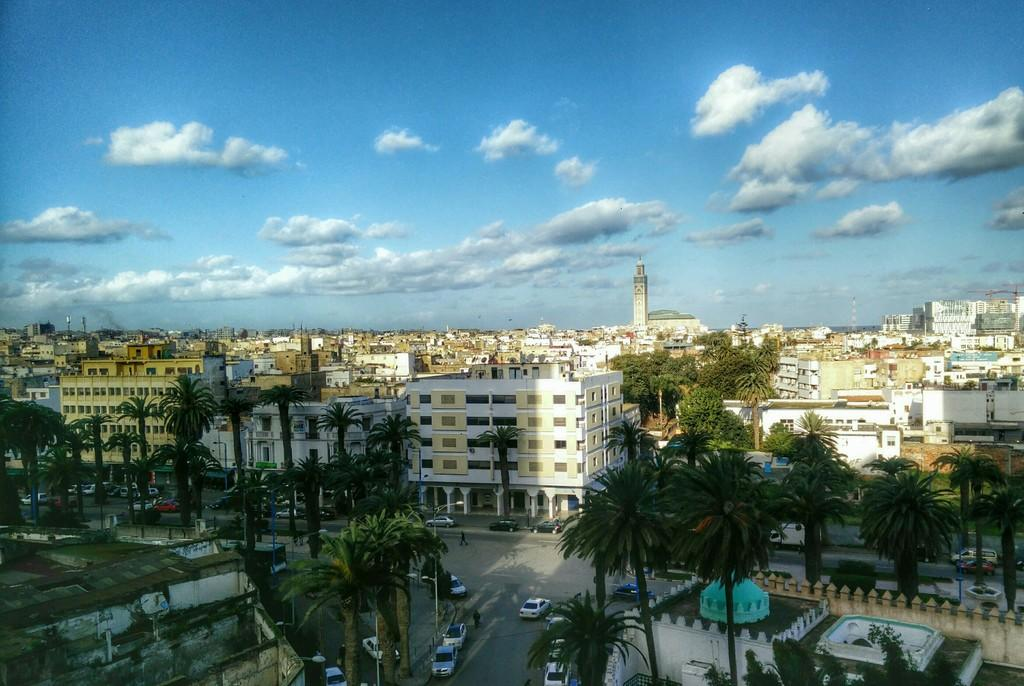What type of vehicles can be seen in the image? There are cars in the image. What other objects or structures are present in the image? There are trees and buildings in the image. What part of the natural environment is visible in the image? The sky is visible in the image. How would you describe the sky in the image? The sky appears to be cloudy in the image. Can you tell me how many brothers are standing next to the cars in the image? There is no mention of a brother or any people in the image; it only features cars, trees, buildings, and the sky. 